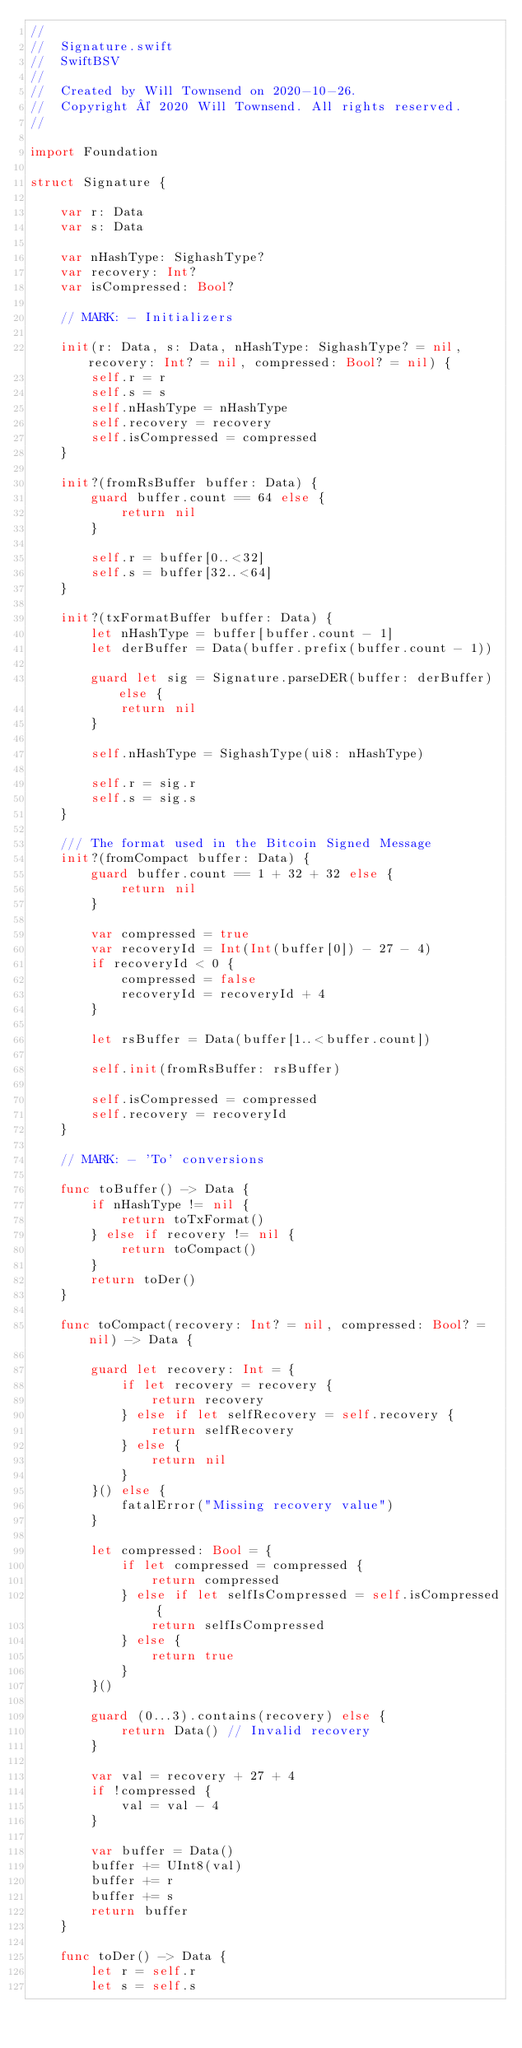Convert code to text. <code><loc_0><loc_0><loc_500><loc_500><_Swift_>//
//  Signature.swift
//  SwiftBSV
//
//  Created by Will Townsend on 2020-10-26.
//  Copyright © 2020 Will Townsend. All rights reserved.
//

import Foundation

struct Signature {

    var r: Data
    var s: Data

    var nHashType: SighashType?
    var recovery: Int?
    var isCompressed: Bool?

    // MARK: - Initializers

    init(r: Data, s: Data, nHashType: SighashType? = nil, recovery: Int? = nil, compressed: Bool? = nil) {
        self.r = r
        self.s = s
        self.nHashType = nHashType
        self.recovery = recovery
        self.isCompressed = compressed
    }

    init?(fromRsBuffer buffer: Data) {
        guard buffer.count == 64 else {
            return nil
        }

        self.r = buffer[0..<32]
        self.s = buffer[32..<64]
    }

    init?(txFormatBuffer buffer: Data) {
        let nHashType = buffer[buffer.count - 1]
        let derBuffer = Data(buffer.prefix(buffer.count - 1))

        guard let sig = Signature.parseDER(buffer: derBuffer) else {
            return nil
        }

        self.nHashType = SighashType(ui8: nHashType)

        self.r = sig.r
        self.s = sig.s
    }

    /// The format used in the Bitcoin Signed Message
    init?(fromCompact buffer: Data) {
        guard buffer.count == 1 + 32 + 32 else {
            return nil
        }

        var compressed = true
        var recoveryId = Int(Int(buffer[0]) - 27 - 4)
        if recoveryId < 0 {
            compressed = false
            recoveryId = recoveryId + 4
        }

        let rsBuffer = Data(buffer[1..<buffer.count])

        self.init(fromRsBuffer: rsBuffer)

        self.isCompressed = compressed
        self.recovery = recoveryId
    }

    // MARK: - 'To' conversions

    func toBuffer() -> Data {
        if nHashType != nil {
            return toTxFormat()
        } else if recovery != nil {
            return toCompact()
        }
        return toDer()
    }

    func toCompact(recovery: Int? = nil, compressed: Bool? = nil) -> Data {

        guard let recovery: Int = {
            if let recovery = recovery {
                return recovery
            } else if let selfRecovery = self.recovery {
                return selfRecovery
            } else {
                return nil
            }
        }() else {
            fatalError("Missing recovery value")
        }

        let compressed: Bool = {
            if let compressed = compressed {
                return compressed
            } else if let selfIsCompressed = self.isCompressed {
                return selfIsCompressed
            } else {
                return true
            }
        }()

        guard (0...3).contains(recovery) else {
            return Data() // Invalid recovery
        }

        var val = recovery + 27 + 4
        if !compressed {
            val = val - 4
        }

        var buffer = Data()
        buffer += UInt8(val)
        buffer += r
        buffer += s
        return buffer
    }

    func toDer() -> Data {
        let r = self.r
        let s = self.s</code> 